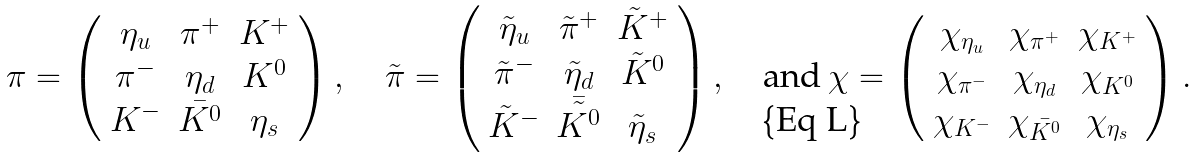Convert formula to latex. <formula><loc_0><loc_0><loc_500><loc_500>\pi = \left ( \begin{array} { c c c } \eta _ { u } & \pi ^ { + } & K ^ { + } \\ \pi ^ { - } & \eta _ { d } & K ^ { 0 } \\ K ^ { - } & \bar { K ^ { 0 } } & \eta _ { s } \end{array} \right ) , \quad \tilde { \pi } = \left ( \begin{array} { c c c } \tilde { \eta } _ { u } & \tilde { \pi } ^ { + } & \tilde { K } ^ { + } \\ \tilde { \pi } ^ { - } & \tilde { \eta } _ { d } & \tilde { K } ^ { 0 } \\ \tilde { K } ^ { - } & \bar { \tilde { K ^ { 0 } } } & \tilde { \eta } _ { s } \end{array} \right ) , \quad \text {and} \, \chi = \left ( \begin{array} { c c c } \chi _ { \eta _ { u } } & \chi _ { \pi ^ { + } } & \chi _ { K ^ { + } } \\ \chi _ { \pi ^ { - } } & \chi _ { \eta _ { d } } & \chi _ { K ^ { 0 } } \\ \chi _ { K ^ { - } } & \chi _ { \bar { K ^ { 0 } } } & \chi _ { \eta _ { s } } \end{array} \right ) .</formula> 